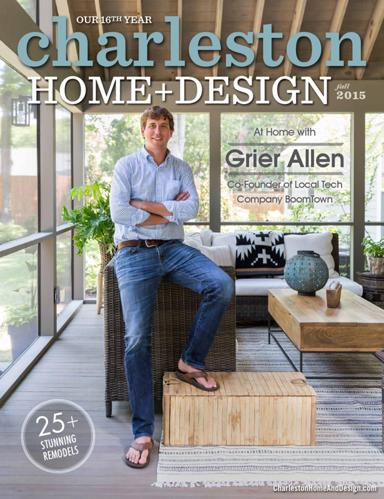What is being celebrated on the cover of Charleston Home Design? The cover of the Charleston Home Design magazine celebrates its 46th anniversary, marking over four decades of inspiring homeowners with innovative design and architecture. 